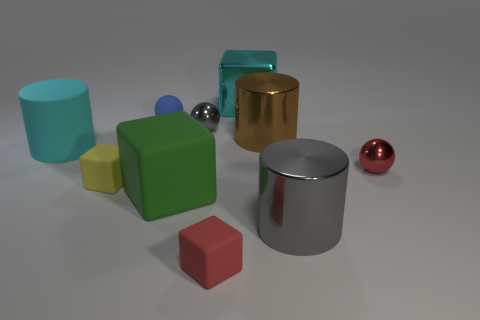Are there more small matte cubes that are left of the tiny red rubber object than red metallic objects in front of the large green matte object?
Your answer should be very brief. Yes. Are there any rubber cylinders to the right of the blue matte ball?
Ensure brevity in your answer.  No. Is there a cyan rubber cylinder of the same size as the green rubber cube?
Ensure brevity in your answer.  Yes. What color is the block that is made of the same material as the large gray object?
Keep it short and to the point. Cyan. What is the material of the yellow thing?
Make the answer very short. Rubber. The red shiny object is what shape?
Provide a succinct answer. Sphere. What number of big cylinders are the same color as the metal cube?
Ensure brevity in your answer.  1. What is the material of the gray object that is behind the small yellow cube left of the large rubber thing that is in front of the yellow block?
Offer a very short reply. Metal. What number of red things are either big matte cubes or balls?
Give a very brief answer. 1. There is a cyan object in front of the metal object that is to the left of the cyan thing that is on the right side of the yellow rubber cube; what size is it?
Make the answer very short. Large. 